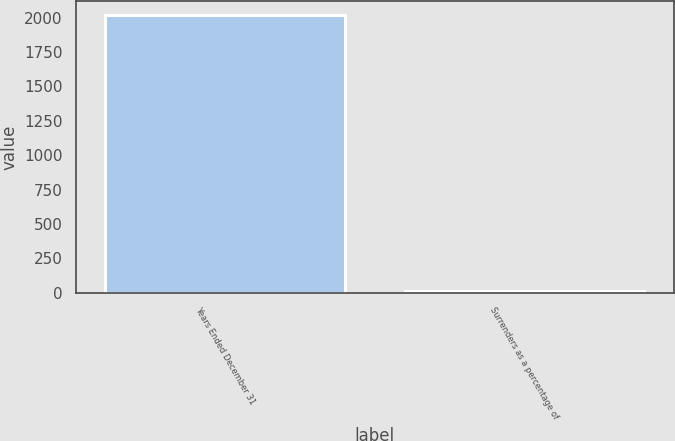Convert chart to OTSL. <chart><loc_0><loc_0><loc_500><loc_500><bar_chart><fcel>Years Ended December 31<fcel>Surrenders as a percentage of<nl><fcel>2016<fcel>8.8<nl></chart> 